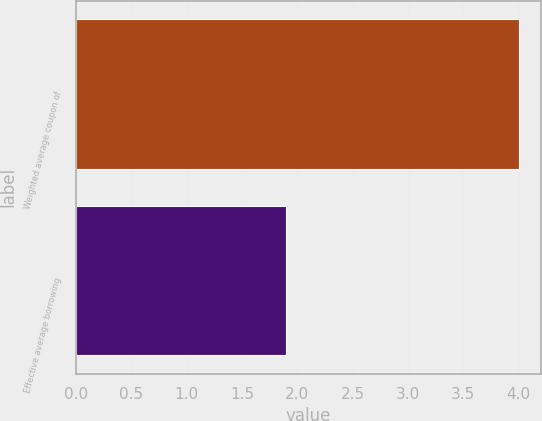Convert chart to OTSL. <chart><loc_0><loc_0><loc_500><loc_500><bar_chart><fcel>Weighted average coupon of<fcel>Effective average borrowing<nl><fcel>4<fcel>1.9<nl></chart> 